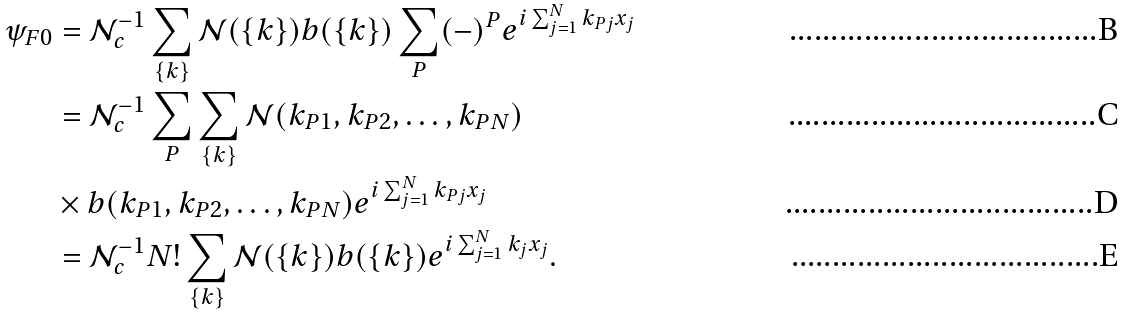Convert formula to latex. <formula><loc_0><loc_0><loc_500><loc_500>\psi _ { F 0 } & = { \mathcal { N } } _ { c } ^ { - 1 } \sum _ { \{ k \} } \mathcal { N } ( { \{ k \} } ) b ( \{ k \} ) \sum _ { P } ( - ) ^ { P } e ^ { i \sum _ { j = 1 } ^ { N } k _ { P j } x _ { j } } \\ & = { \mathcal { N } } _ { c } ^ { - 1 } \sum _ { P } \sum _ { \{ k \} } \mathcal { N } ( k _ { P 1 } , k _ { P 2 } , \dots , k _ { P N } ) \\ & \times b ( k _ { P 1 } , k _ { P 2 } , \dots , k _ { P N } ) e ^ { i \sum _ { j = 1 } ^ { N } k _ { P j } x _ { j } } \\ & = { \mathcal { N } } _ { c } ^ { - 1 } N ! \sum _ { \{ k \} } \mathcal { N } ( \{ k \} ) b ( \{ k \} ) e ^ { i \sum _ { j = 1 } ^ { N } k _ { j } x _ { j } } .</formula> 